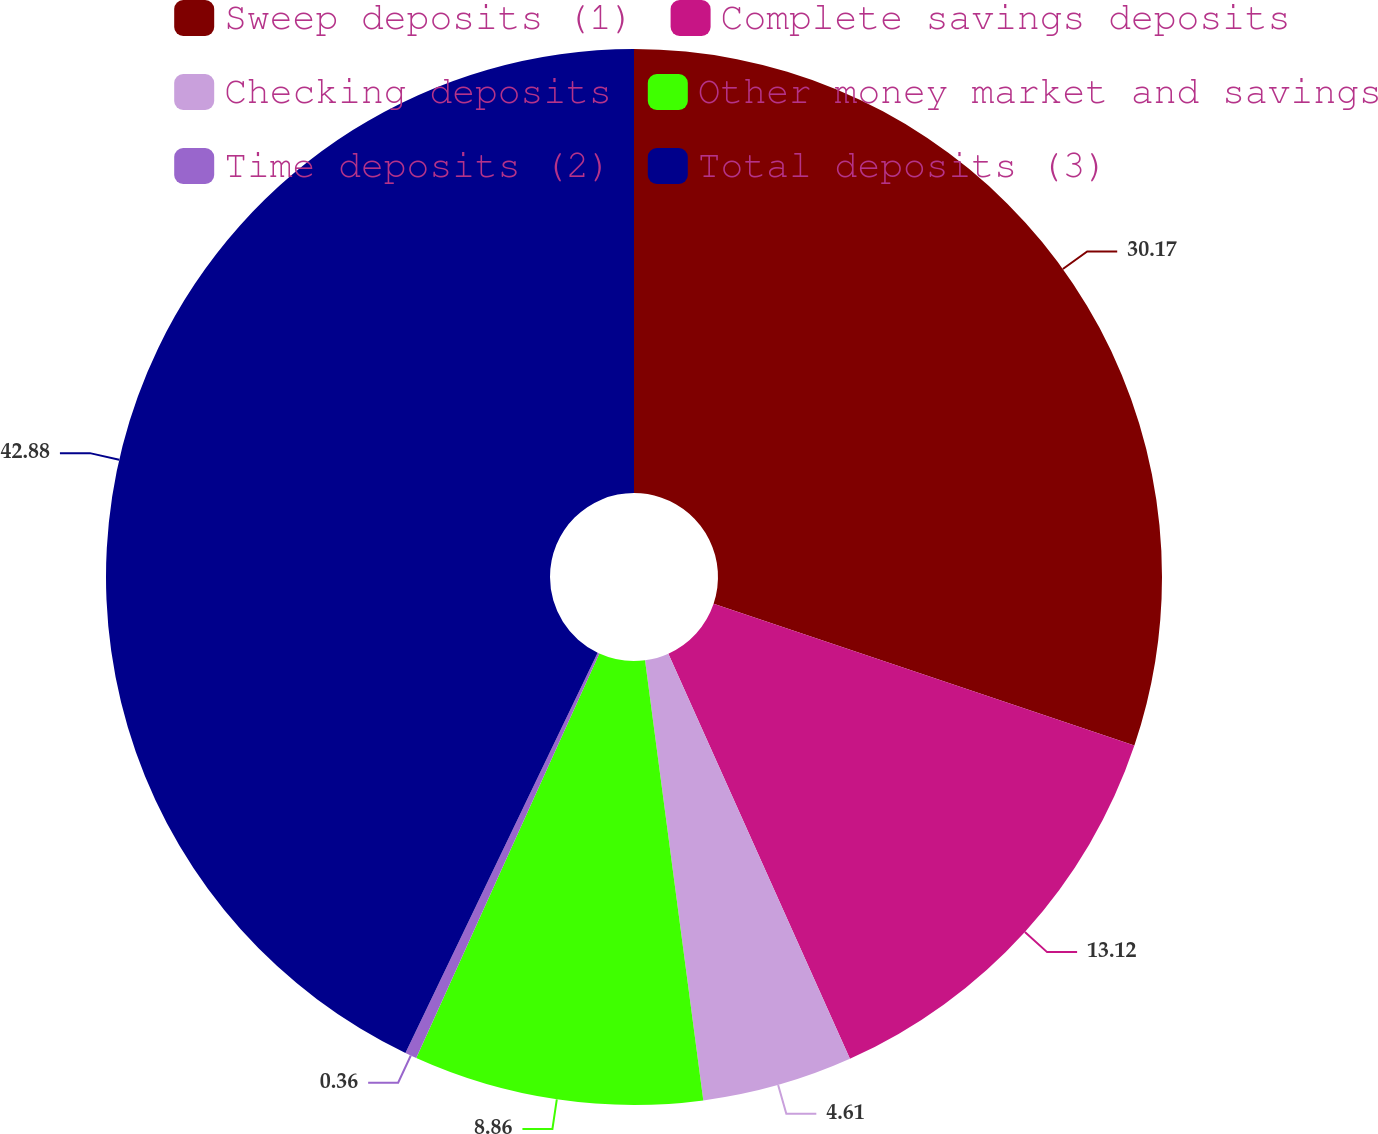Convert chart to OTSL. <chart><loc_0><loc_0><loc_500><loc_500><pie_chart><fcel>Sweep deposits (1)<fcel>Complete savings deposits<fcel>Checking deposits<fcel>Other money market and savings<fcel>Time deposits (2)<fcel>Total deposits (3)<nl><fcel>30.17%<fcel>13.12%<fcel>4.61%<fcel>8.86%<fcel>0.36%<fcel>42.87%<nl></chart> 